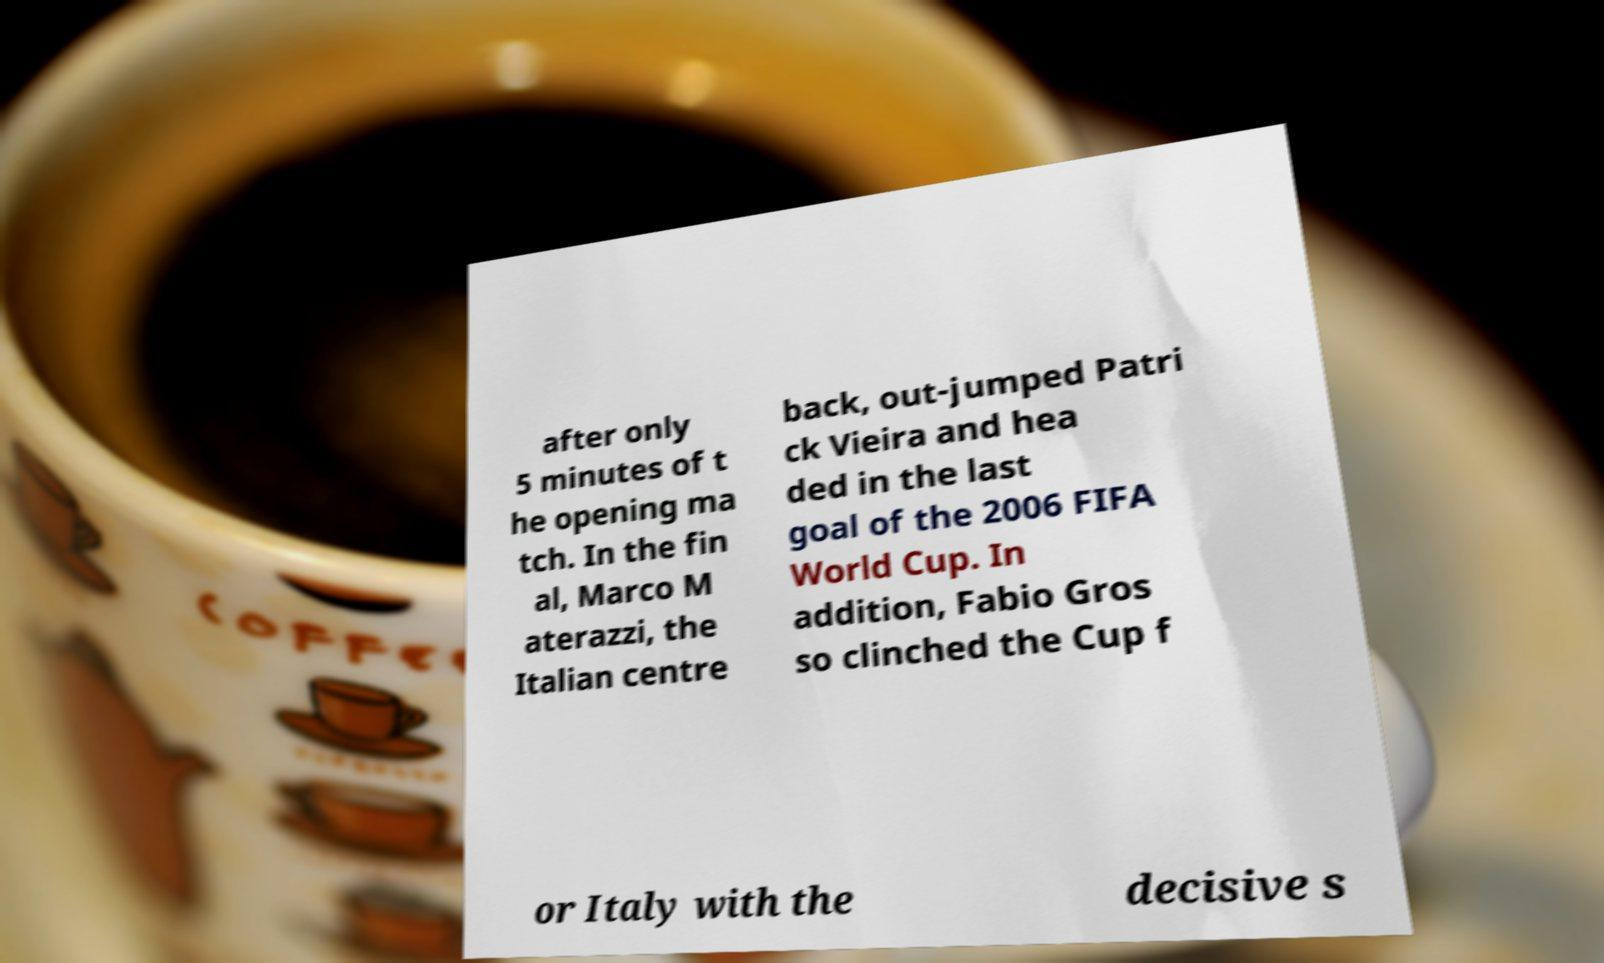I need the written content from this picture converted into text. Can you do that? after only 5 minutes of t he opening ma tch. In the fin al, Marco M aterazzi, the Italian centre back, out-jumped Patri ck Vieira and hea ded in the last goal of the 2006 FIFA World Cup. In addition, Fabio Gros so clinched the Cup f or Italy with the decisive s 